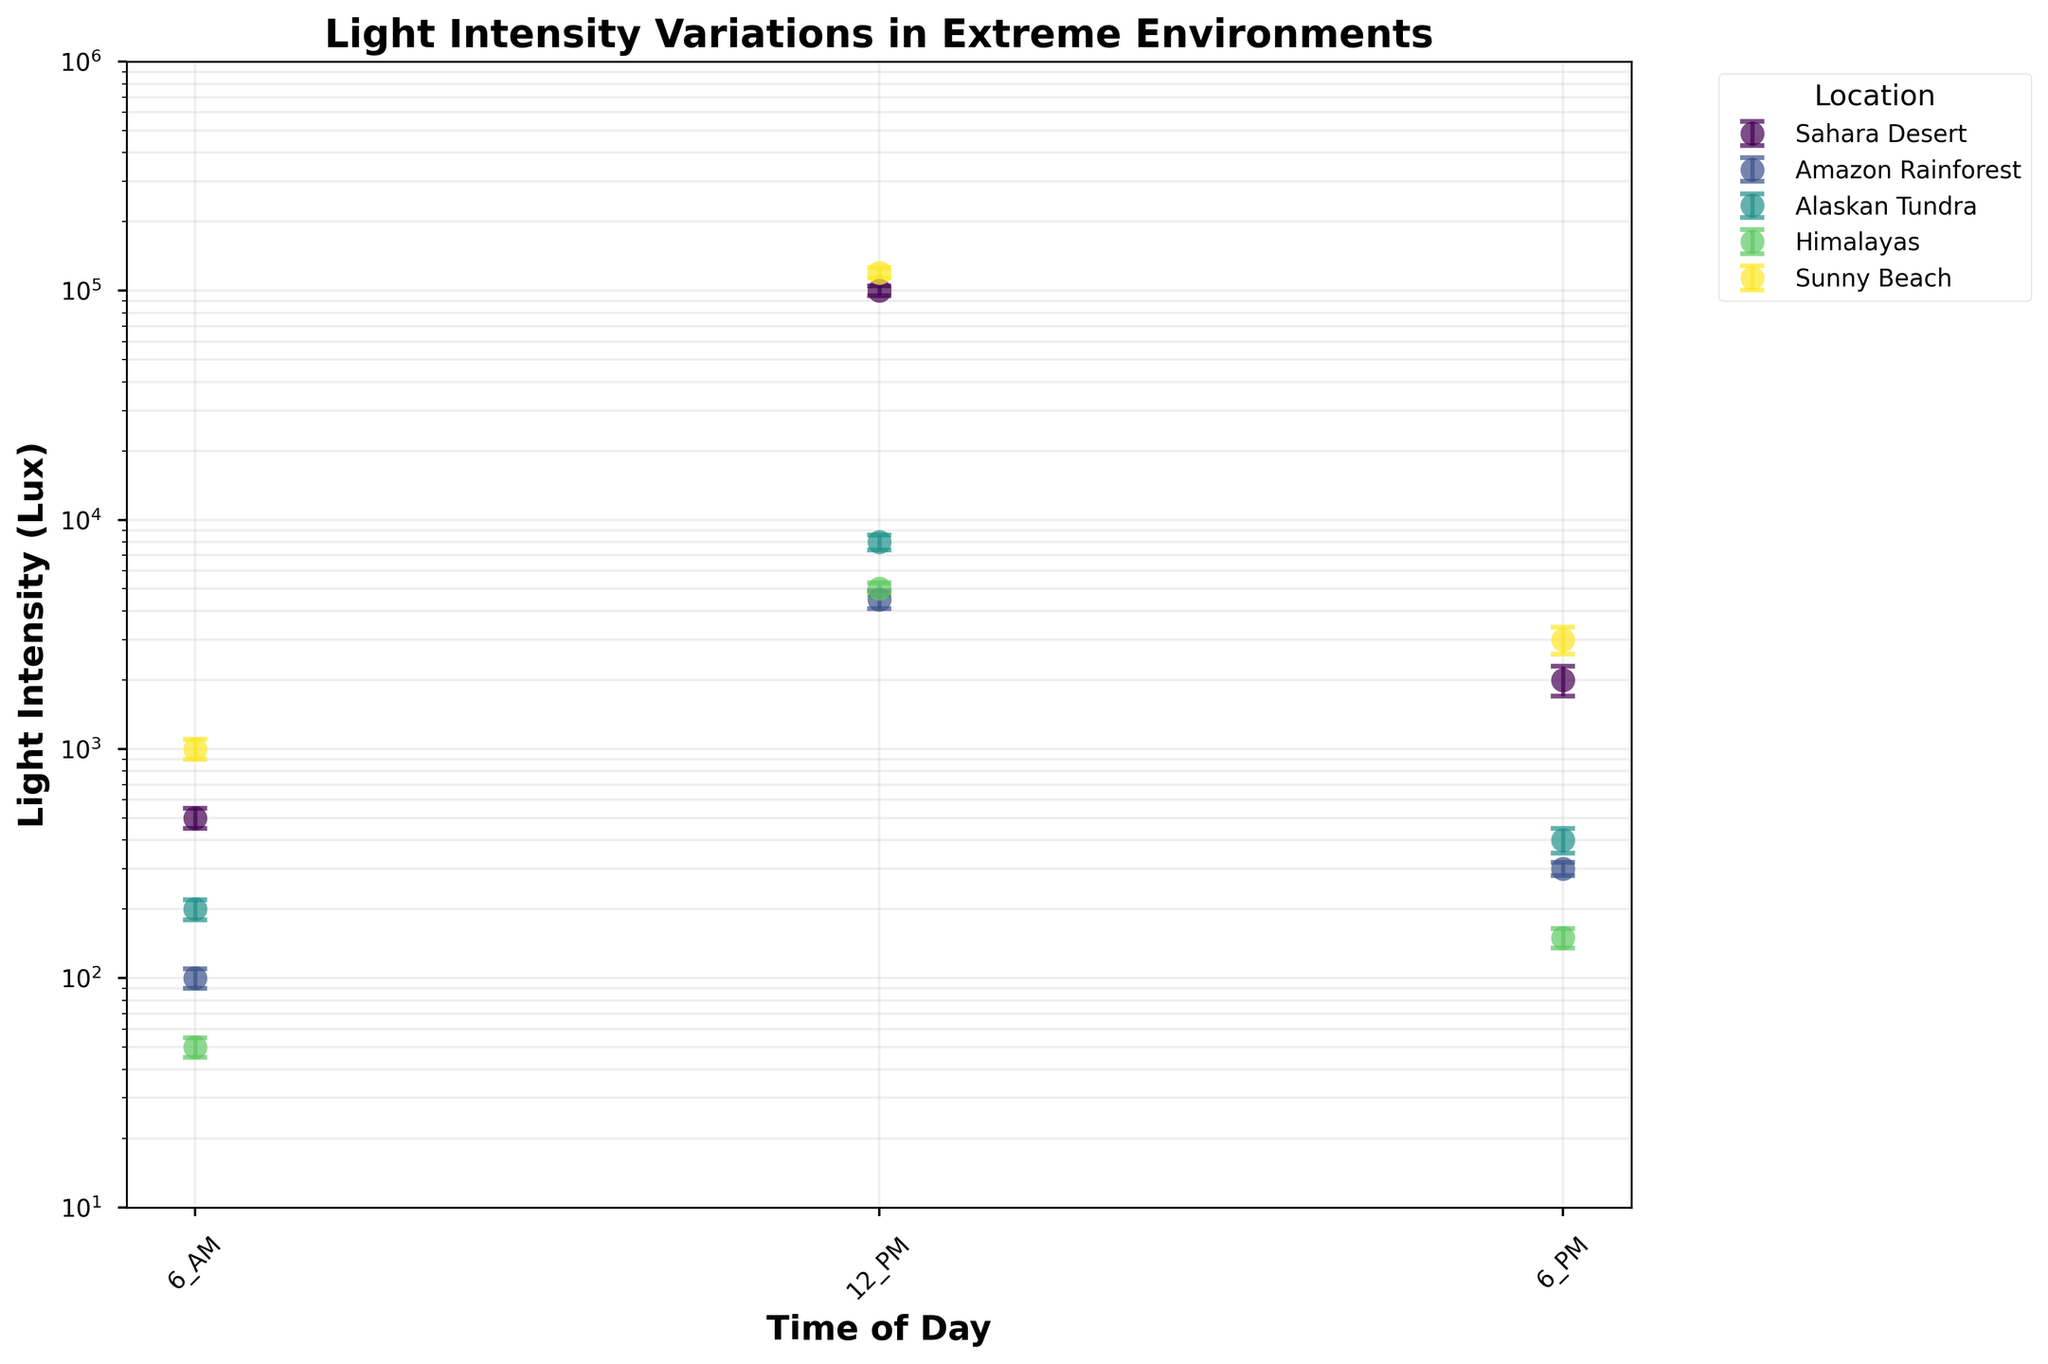What is the title of the figure? The title of the figure is often found at the top of the chart and clearly denotes what the figure is about. In this case, it provides information about variations in light intensity across different outdoor locations.
Answer: Light Intensity Variations in Extreme Environments What are the time intervals shown on the x-axis? To determine the time intervals, look at the labels on the x-axis. They should denote different times of day when light intensity was measured.
Answer: 6 AM, 12 PM, 6 PM Which location exhibits the highest average light intensity at noon? Identify the location associated with the highest data point on the y-axis corresponding to the 12 PM label. The highest average light intensity at noon should be the highest point among all noon data points.
Answer: Sunny Beach Which location has the lowest average light intensity at 6 AM? To find the location with the lowest average light intensity at 6 AM, look at the data points corresponding to 6 AM on the x-axis and find the one with the smallest value on the y-axis.
Answer: Himalayas How does the light intensity at 6 PM in the Amazon Rainforest compare to that in the Alaskan Tundra? Compare the y-values of the data points corresponding to the two locations at 6 PM. Observe which value is higher and which is lower.
Answer: Amazons Rainforest has higher light intensity What is the average of the light intensity at 12 PM across all locations? To compute the average, first find the values for light intensity at 12 PM for each location (Sahara Desert, Amazon Rainforest, Alaskan Tundra, Himalayas, Sunny Beach), then sum these values and divide by the number of locations.
Answer: 47500 lux What is the range of light intensity values for the Sahara Desert throughout the day? Identify the highest and lowest points of light intensity for the Sahara Desert and compute their difference. The highest value is at 12 PM, and the lowest at 6 AM.
Answer: 99500 lux Which location shows the largest error margin in light intensity measurements at 12 PM? Look at the error bars for each location at 12 PM, and determine which one is the largest by visual comparison.
Answer: Sunny Beach Is there any data point where the light intensity is less than 100 lux? If so, which location and time is it? Identify any data points below the 100 lux mark by examining the y-axis values and finding associated locations and times.
Answer: Himalayas at 6 AM Which location has the largest drop in light intensity when comparing 12 PM to 6 PM? Calculate the difference in light intensity from 12 PM to 6 PM for all locations and identify the one with the largest negative difference.
Answer: Sahara Desert 